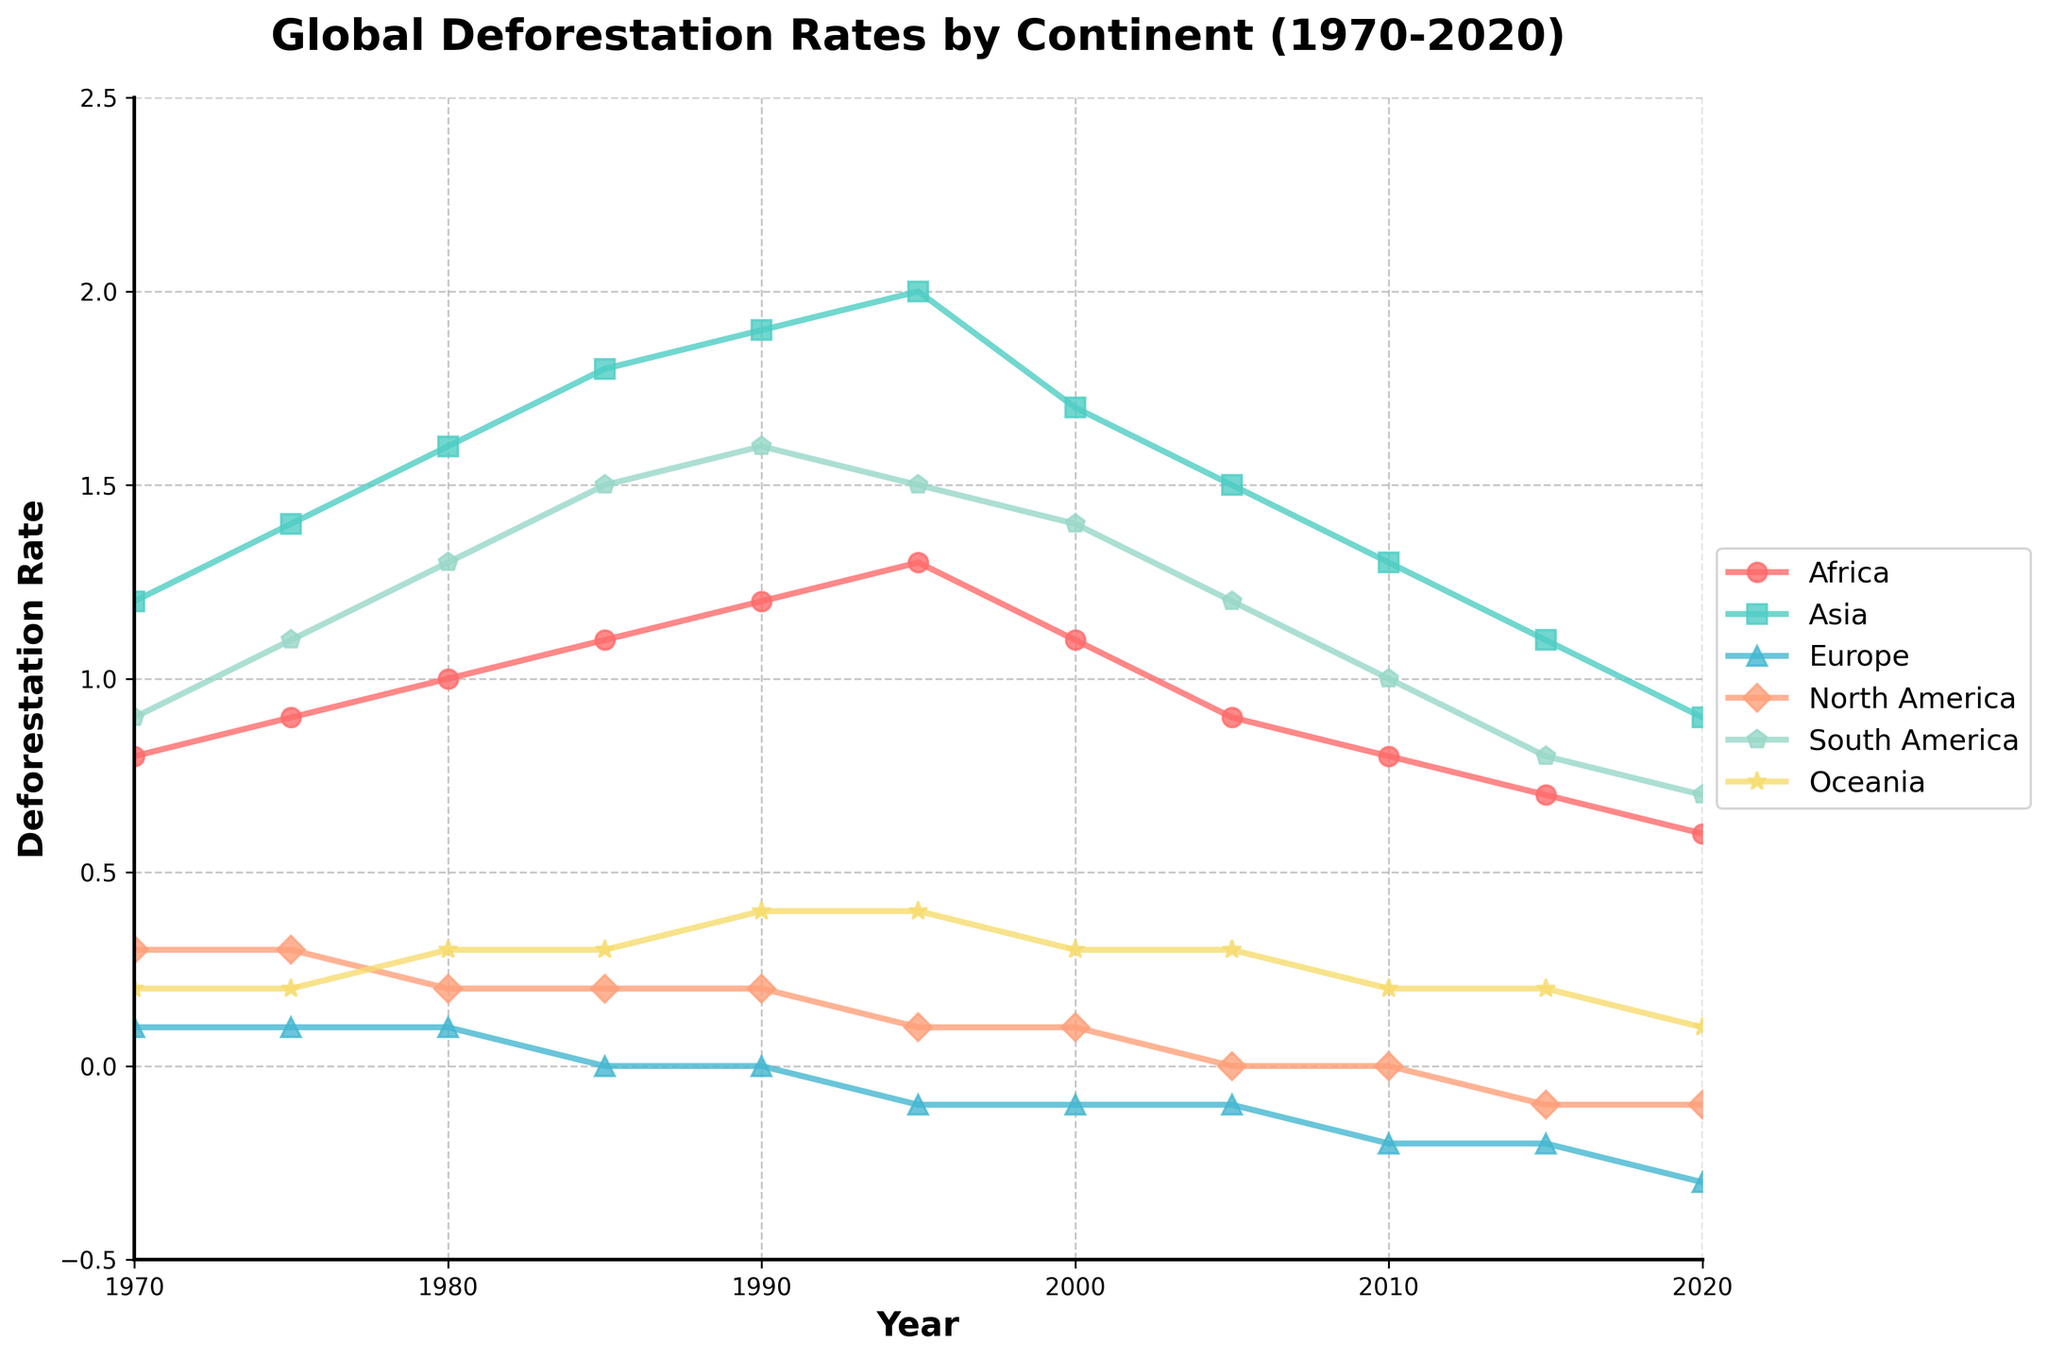What's the overall trend for deforestation rates in Africa over the last 50 years? To determine the trend for Africa, observe how the data points change from 1970 to 2020. The deforestation rate in Africa rose from 0.8 in 1970 to a peak of 1.3 in 1995 and then declined to 0.6 by 2020.
Answer: An initial increase followed by a decline Compare the deforestation rate fluctuations between Asia and South America. Which continent exhibited the larger fluctuations? Examine the values for both continents from 1970 to 2020. Asia's deforestation rate ranges from 1.2 to 2.0, and South America's ranges from 0.7 to 1.6. South America's range (0.9) is larger than Asia's range (0.8).
Answer: South America What is the year when Europe’s deforestation rate first became negative, and what was the rate at that time? Look at Europe's data and find the first year it turns negative. In 1995, the deforestation rate becomes -0.1 for the first time.
Answer: 1995, -0.1 How did North America's deforestation rate change from 1970 to 2020? Check the deforestation rates for North America across the years. The rate starts at 0.3 in 1970, decreases gradually, and becomes negative (-0.1) by 2020.
Answer: Decreased to -0.1 Which continent had the most consistent deforestation rate over the entire period? Consistency can be observed by looking for the continent with the least variation across the data points. North America and Europe both have less fluctuation but North America has had more negative values. Europe remains consistently near or below zero compared to others.
Answer: Europe What is the combined deforestation rate for Africa and Asia in 1980? To find the combined rate for Africa and Asia in 1980, add their respective rates: 1.0 (Africa) + 1.6 (Asia) = 2.6.
Answer: 2.6 By how much did deforestation rates decrease in South America from its peak in 1990 to 2020? Identify the peak rate for South America in 1990 (1.6) and then subtract the rate in 2020 (0.7). The decrease is 1.6 - 0.7 = 0.9.
Answer: 0.9 Which continent experienced deforestation rate values both positive and negative over this period? Look for continents with both positive and negative values in the dataset. Europe shows values such as 0.1 (positive) and -0.3 (negative).
Answer: Europe In which year did Oceania experience its highest deforestation rate, and what was the rate? Find the highest value for Oceania in the dataset, which occurs in 1990 with a rate of 0.4.
Answer: 1990, 0.4 What is the average deforestation rate in Oceania from 1970 to 2020? Sum the deforestation rates for Oceania and divide by the number of years. (0.2+0.2+0.3+0.3+0.4+0.4+0.3+0.3+0.2+0.2+0.1) / 11 = 0.27.
Answer: 0.27 